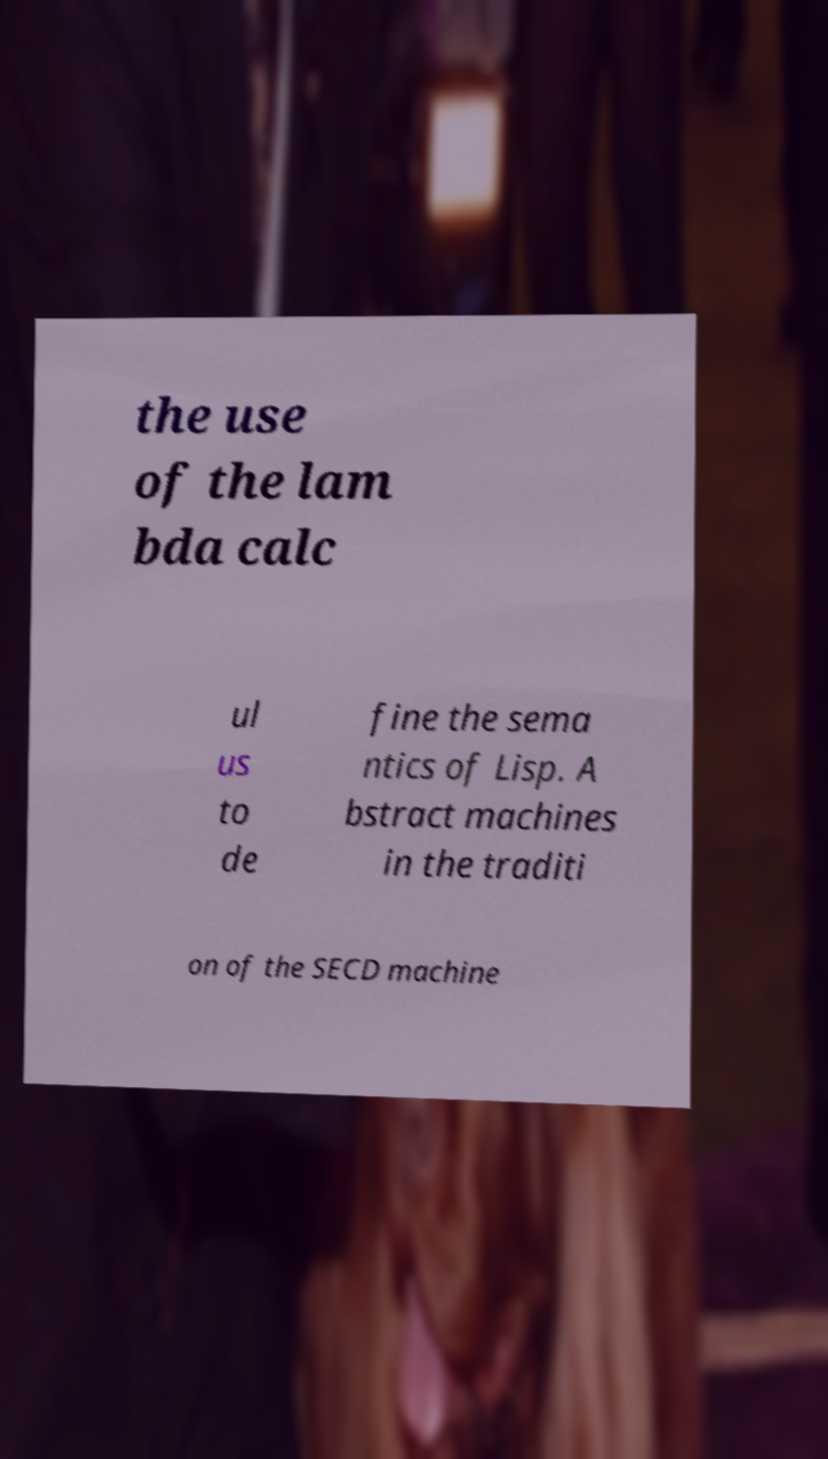Can you read and provide the text displayed in the image?This photo seems to have some interesting text. Can you extract and type it out for me? the use of the lam bda calc ul us to de fine the sema ntics of Lisp. A bstract machines in the traditi on of the SECD machine 